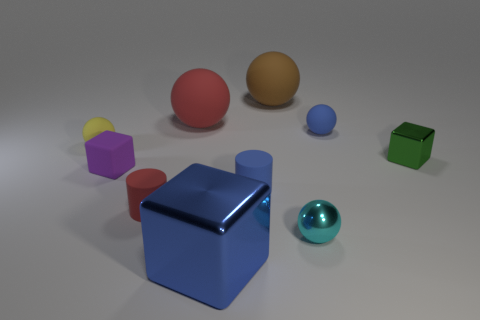Is the size of the yellow matte object the same as the blue matte cylinder that is to the left of the small metallic block?
Your answer should be very brief. Yes. Are there more spheres that are to the right of the large blue metal object than blue metal blocks?
Your response must be concise. Yes. What is the size of the cyan object that is made of the same material as the big block?
Offer a very short reply. Small. Is there another big metallic block of the same color as the large metallic block?
Your response must be concise. No. How many objects are tiny brown metallic objects or tiny spheres left of the big metallic object?
Keep it short and to the point. 1. Is the number of purple shiny things greater than the number of small purple rubber cubes?
Your response must be concise. No. The rubber sphere that is the same color as the large shiny cube is what size?
Your answer should be very brief. Small. Is there a tiny cylinder made of the same material as the tiny purple object?
Provide a succinct answer. Yes. What is the shape of the small matte object that is behind the purple block and right of the purple block?
Provide a succinct answer. Sphere. How many other objects are the same shape as the big brown object?
Provide a short and direct response. 4. 